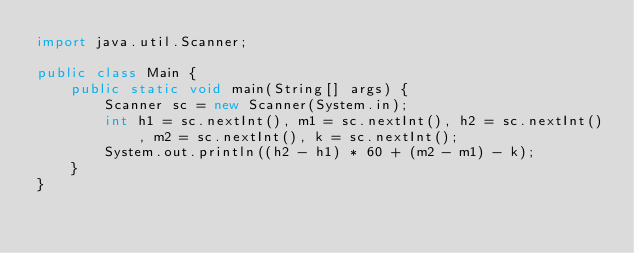<code> <loc_0><loc_0><loc_500><loc_500><_Java_>import java.util.Scanner;
 
public class Main {
    public static void main(String[] args) {
        Scanner sc = new Scanner(System.in);
        int h1 = sc.nextInt(), m1 = sc.nextInt(), h2 = sc.nextInt(), m2 = sc.nextInt(), k = sc.nextInt();
        System.out.println((h2 - h1) * 60 + (m2 - m1) - k);
    }
}</code> 